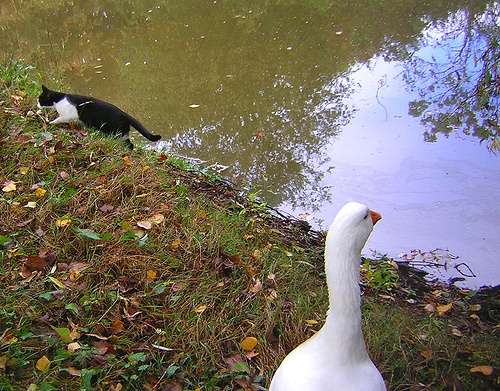Describe the objects in this image and their specific colors. I can see bird in olive, lavender, and darkgray tones and cat in olive, black, gray, and lightgray tones in this image. 